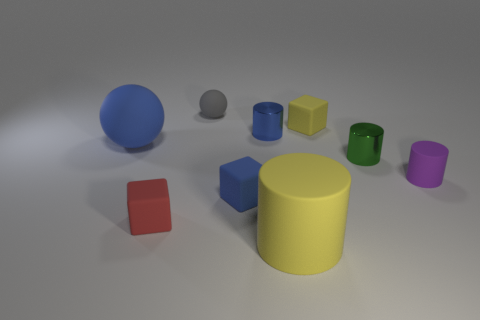Subtract 1 cylinders. How many cylinders are left? 3 Add 1 tiny yellow balls. How many objects exist? 10 Subtract all blocks. How many objects are left? 6 Subtract 0 cyan balls. How many objects are left? 9 Subtract all small red matte objects. Subtract all small yellow matte objects. How many objects are left? 7 Add 7 small gray rubber balls. How many small gray rubber balls are left? 8 Add 5 big blue balls. How many big blue balls exist? 6 